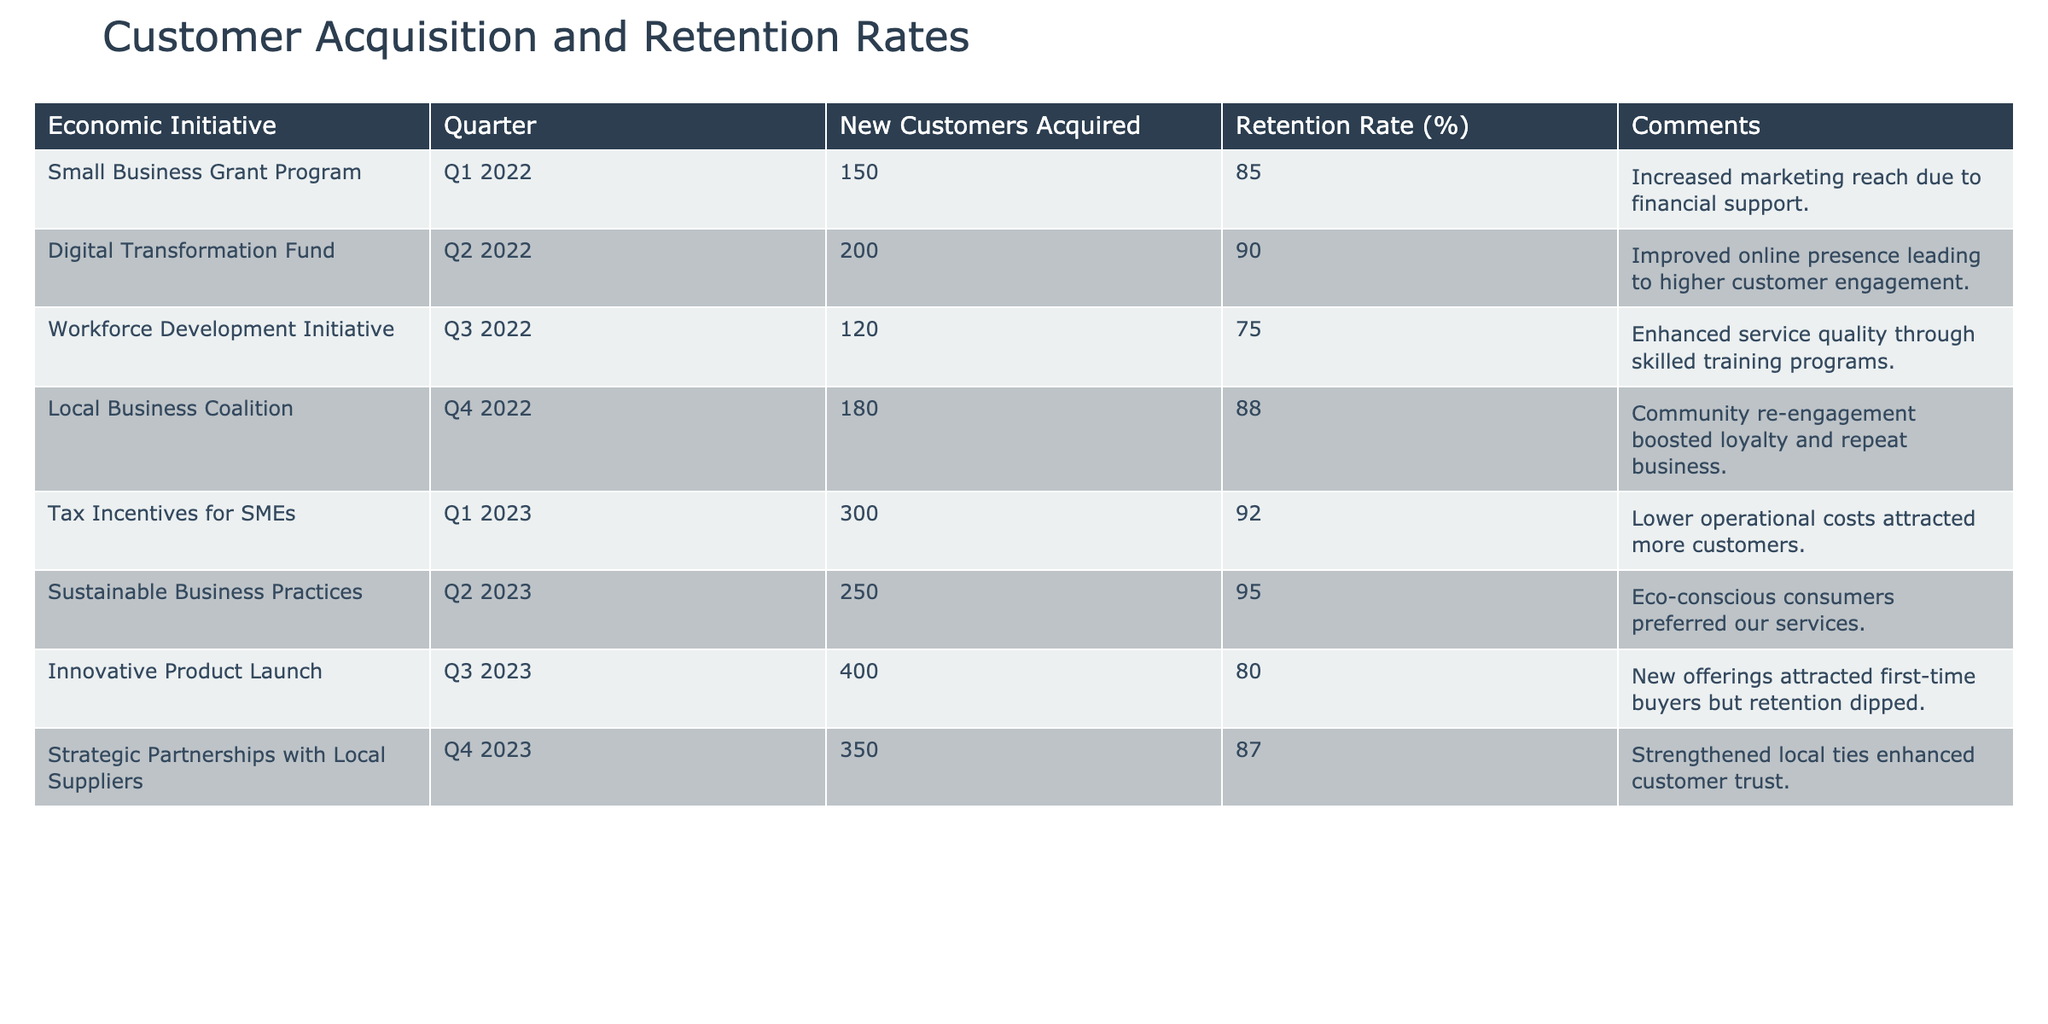What is the retention rate for the Tax Incentives for SMEs initiative in Q1 2023? The table shows that the retention rate for the Tax Incentives for SMEs initiative is listed as 92%.
Answer: 92% How many new customers were acquired during the Digital Transformation Fund initiative? The table indicates that 200 new customers were acquired during the Digital Transformation Fund initiative in Q2 2022.
Answer: 200 Which initiative had the highest number of new customers acquired, and how many were there? Reviewing the table, the Innovative Product Launch initiative had the highest number of new customers acquired, with a total of 400.
Answer: 400 (Innovative Product Launch) What is the average retention rate for all initiatives listed? To find the average, add all retention rates: (85 + 90 + 75 + 88 + 92 + 95 + 80 + 87) = 717, and divide by 8 (the number of initiatives) which equals 89.625, rounded to two decimal places is 89.63.
Answer: 89.63 Did the Local Business Coalition initiative improve customer retention compared to the Workforce Development Initiative? The Local Business Coalition had a retention rate of 88%, while the Workforce Development Initiative had a retention rate of 75%. Since 88% is greater than 75%, the answer is yes.
Answer: Yes How many new customers were acquired in total from Q1 2022 to Q4 2023? Summing up the new customers acquired: 150 (Q1 2022) + 200 (Q2 2022) + 120 (Q3 2022) + 180 (Q4 2022) + 300 (Q1 2023) + 250 (Q2 2023) + 400 (Q3 2023) + 350 (Q4 2023) = 1980 new customers in total.
Answer: 1980 Was the retention rate for the Sustainable Business Practices initiative higher than the retention rate for the Innovative Product Launch initiative? The retention rate for the Sustainable Business Practices initiative is 95%, and for the Innovative Product Launch, it is 80%. Since 95% is greater than 80%, the answer is yes.
Answer: Yes Which quarter saw the lowest customer retention rate, and what was that rate? Looking through the table, the Workforce Development Initiative in Q3 2022 had the lowest retention rate at 75%.
Answer: Q3 2022, 75% 